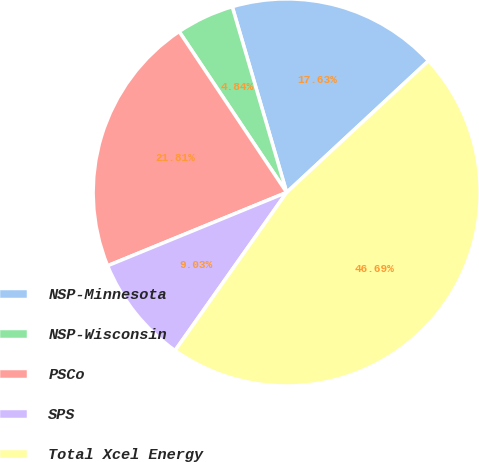Convert chart. <chart><loc_0><loc_0><loc_500><loc_500><pie_chart><fcel>NSP-Minnesota<fcel>NSP-Wisconsin<fcel>PSCo<fcel>SPS<fcel>Total Xcel Energy<nl><fcel>17.63%<fcel>4.84%<fcel>21.81%<fcel>9.03%<fcel>46.69%<nl></chart> 